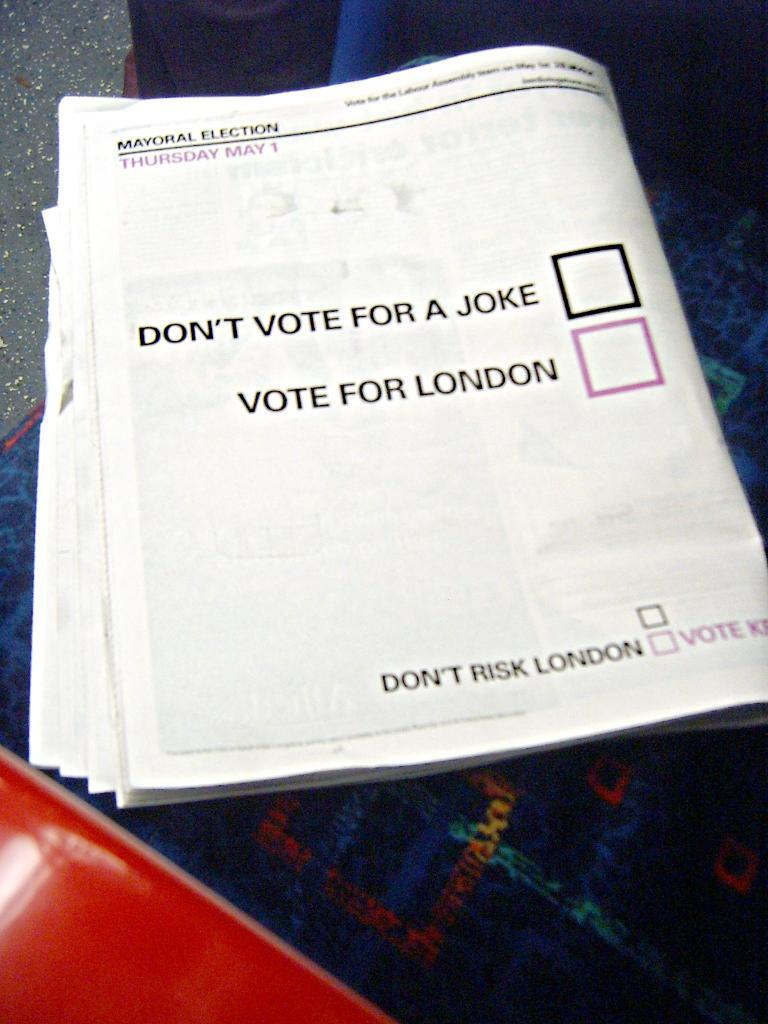<image>
Offer a succinct explanation of the picture presented. a page in a pamphlet that says don't vote for a joke 